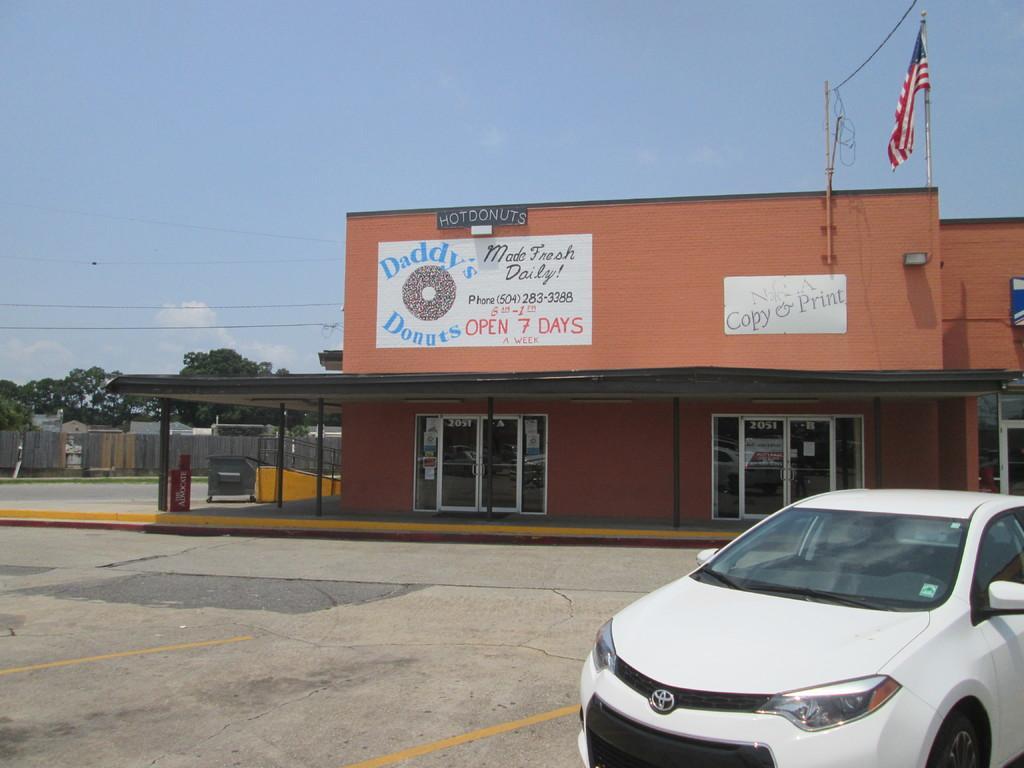Can you describe this image briefly? In this image there is a building at middle of this image. There is one flag at top right corner of this image and there is one current pole left side to this flag. there are two windows at middle of this image. and there is one car at bottom right corner of this image. There are some trees at left side of this image. There is a boundary wall at left side of this image and there is a sky at top of this image. 